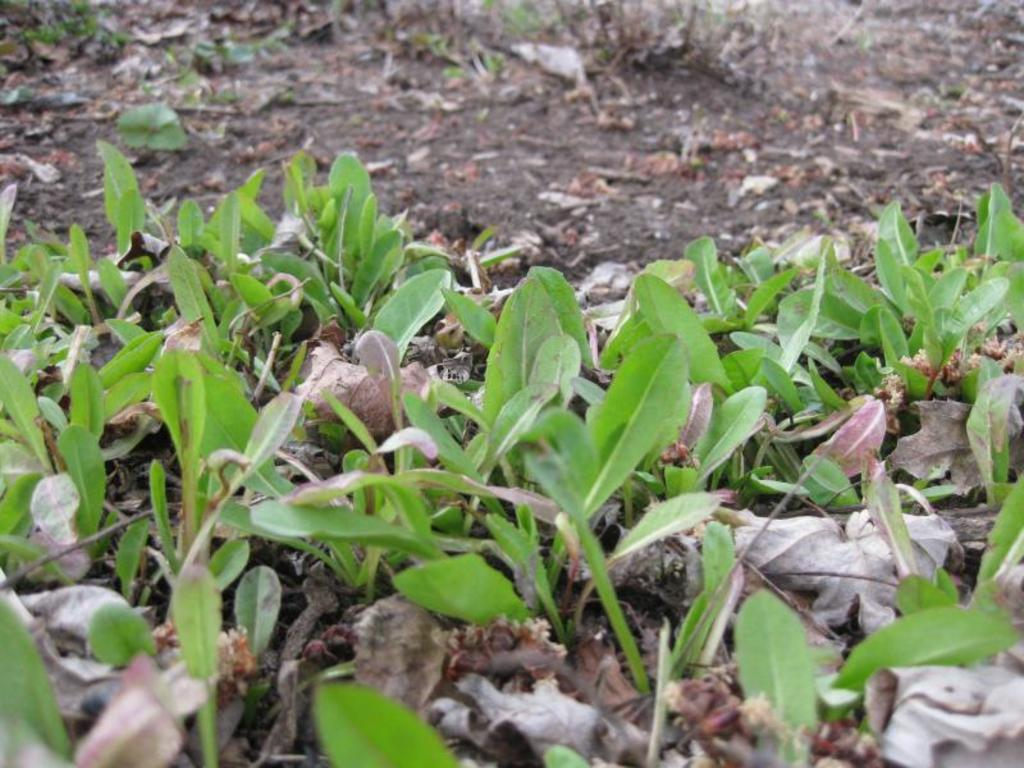What type of vegetation can be seen on the ground in the image? There are plants on the ground in the image. What else can be found on the ground in the image? There are dried leaves on the ground in the image. How does the jellyfish contribute to the image? There is no jellyfish present in the image. 